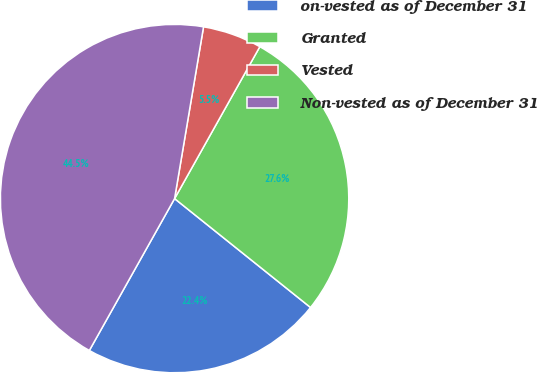Convert chart. <chart><loc_0><loc_0><loc_500><loc_500><pie_chart><fcel>on-vested as of December 31<fcel>Granted<fcel>Vested<fcel>Non-vested as of December 31<nl><fcel>22.39%<fcel>27.61%<fcel>5.48%<fcel>44.52%<nl></chart> 